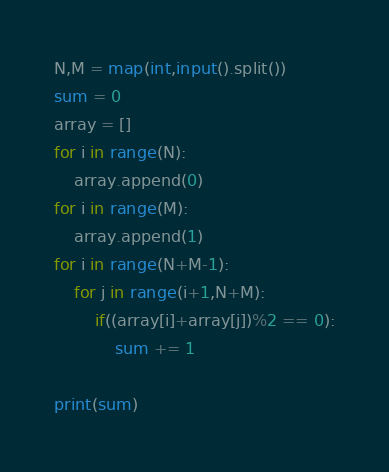Convert code to text. <code><loc_0><loc_0><loc_500><loc_500><_Python_>N,M = map(int,input().split())
sum = 0
array = []
for i in range(N):
    array.append(0)
for i in range(M):
    array.append(1)
for i in range(N+M-1):
    for j in range(i+1,N+M):
        if((array[i]+array[j])%2 == 0):
            sum += 1

print(sum)
</code> 